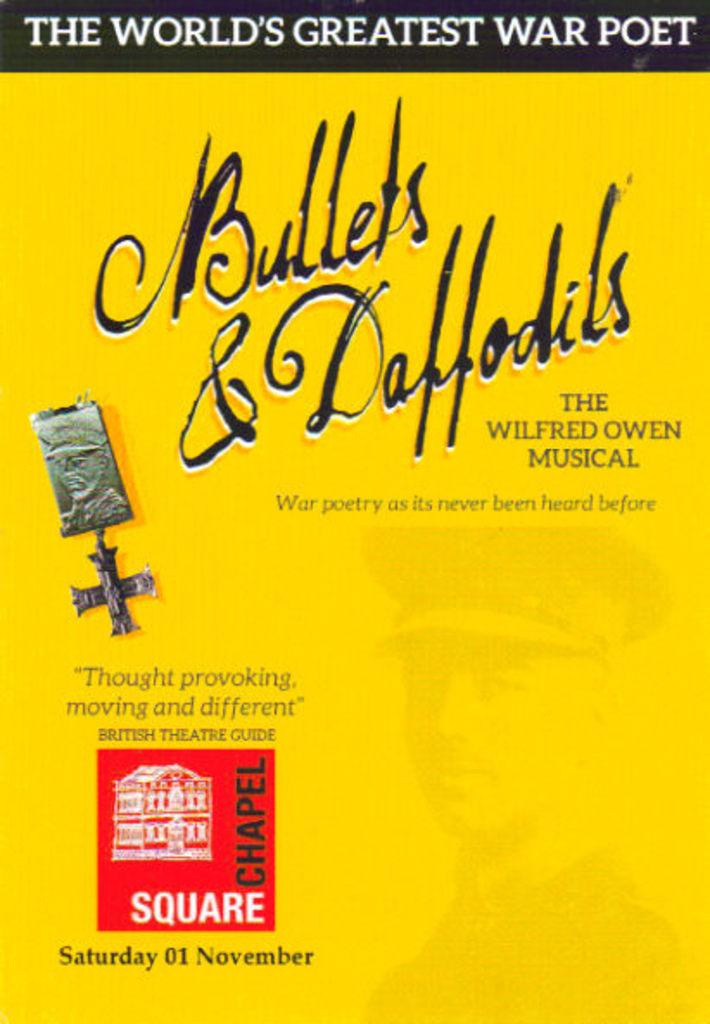What is the date of this event?
Your answer should be very brief. November 1. Is this about a poet?
Provide a succinct answer. Yes. 